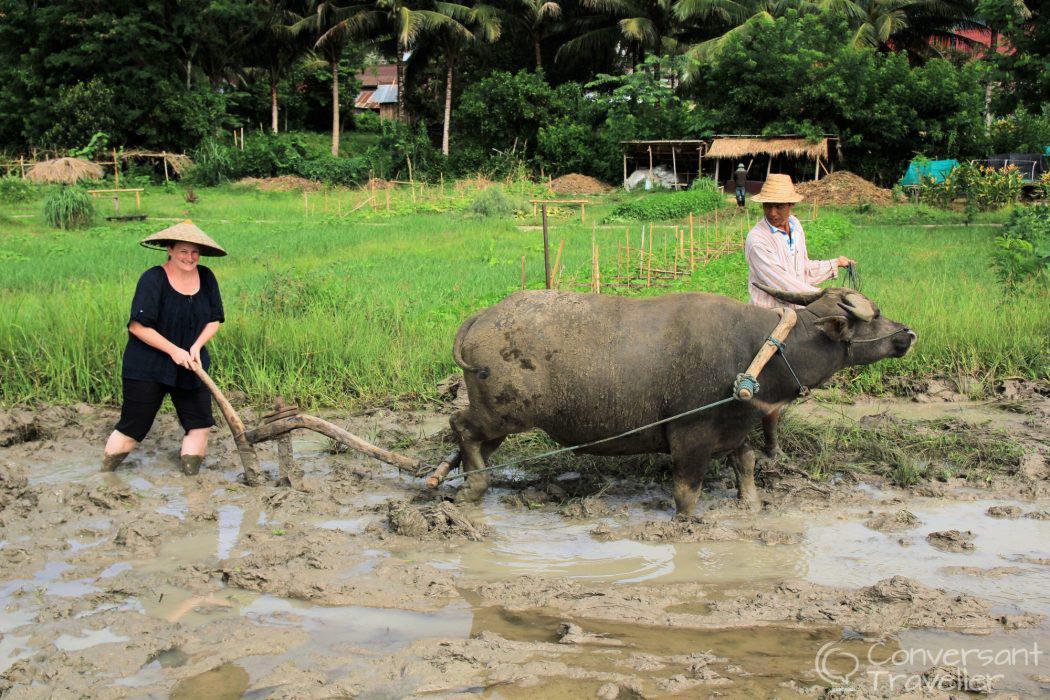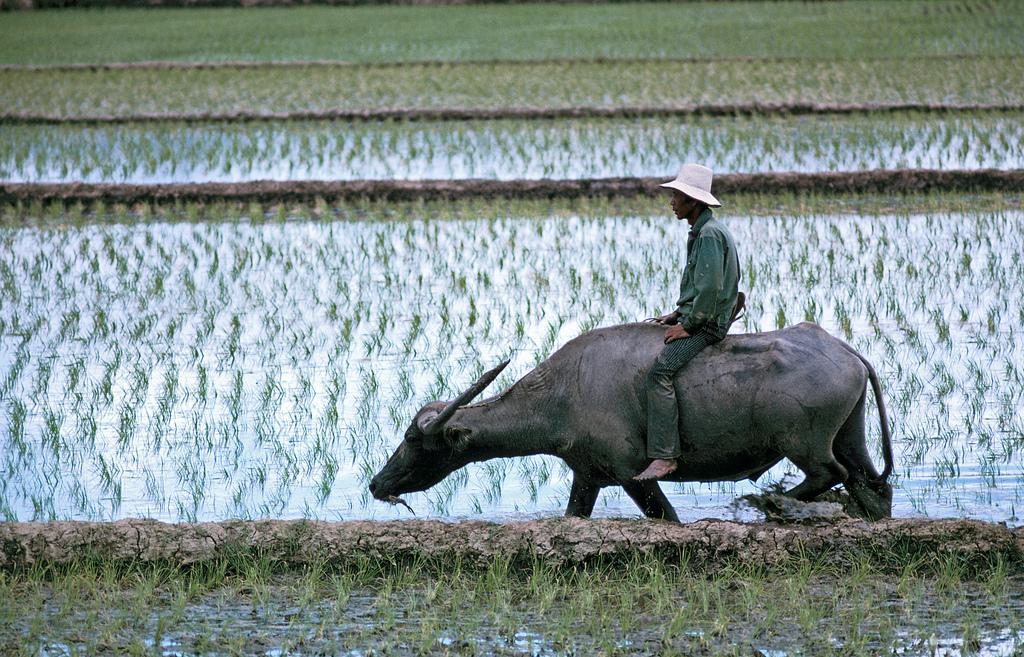The first image is the image on the left, the second image is the image on the right. Assess this claim about the two images: "The right image shows one woman walking leftward behind a plow pulled by one ox through a wet field, and the left image shows one man walking rightward behind a plow pulled by one ox through a wet field.". Correct or not? Answer yes or no. No. The first image is the image on the left, the second image is the image on the right. Analyze the images presented: Is the assertion "Each image shows a person walking behind an ox pulling a tiller" valid? Answer yes or no. No. 